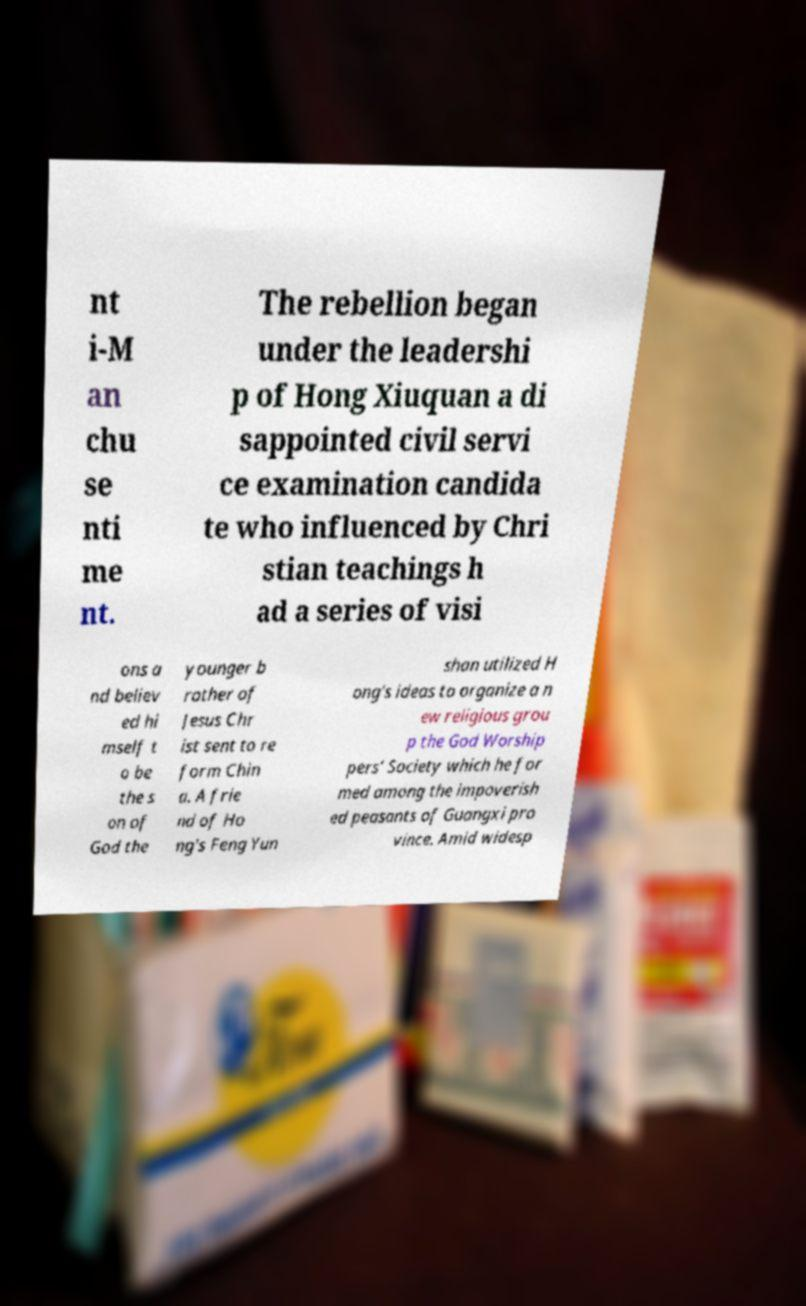What messages or text are displayed in this image? I need them in a readable, typed format. nt i-M an chu se nti me nt. The rebellion began under the leadershi p of Hong Xiuquan a di sappointed civil servi ce examination candida te who influenced by Chri stian teachings h ad a series of visi ons a nd believ ed hi mself t o be the s on of God the younger b rother of Jesus Chr ist sent to re form Chin a. A frie nd of Ho ng's Feng Yun shan utilized H ong's ideas to organize a n ew religious grou p the God Worship pers’ Society which he for med among the impoverish ed peasants of Guangxi pro vince. Amid widesp 